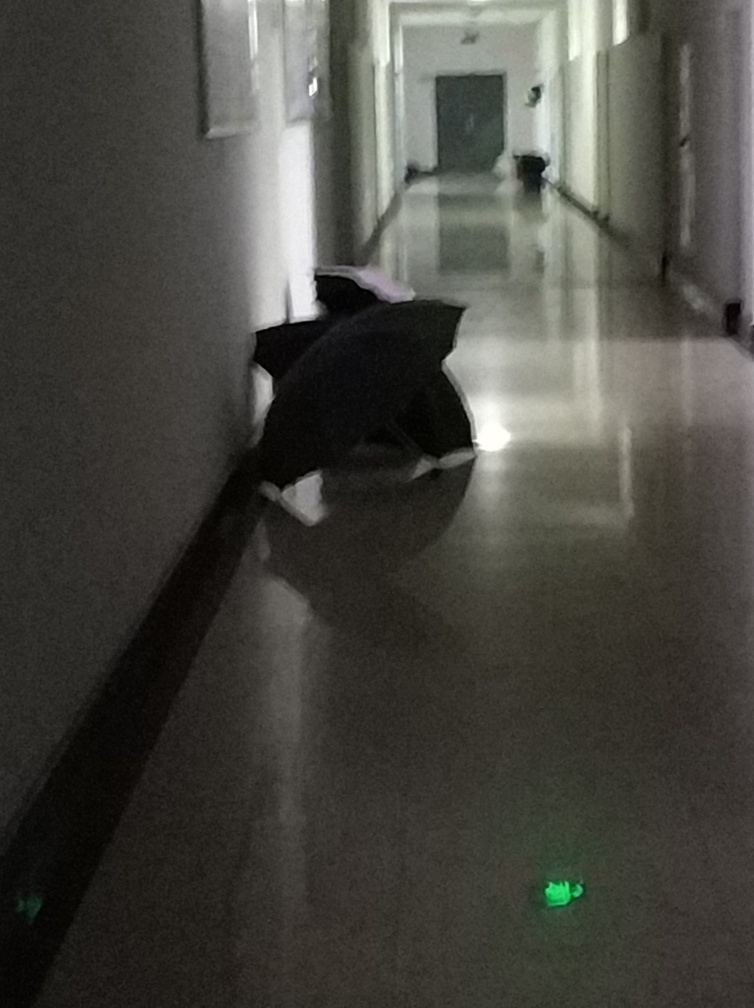What is the overall clarity of the image?
A. Unsatisfactory
B. Excellent
C. Poor
D. Acceptable The overall clarity of the image is unsatisfactory due to its low light conditions and substantial blurriness, making it difficult to discern details. However, some features such as the corridor, doors, and an open umbrella can be identified, which could lead to the conclusion that in a very minimal sense, the image clarity is barely acceptable if generous leniency is applied. 